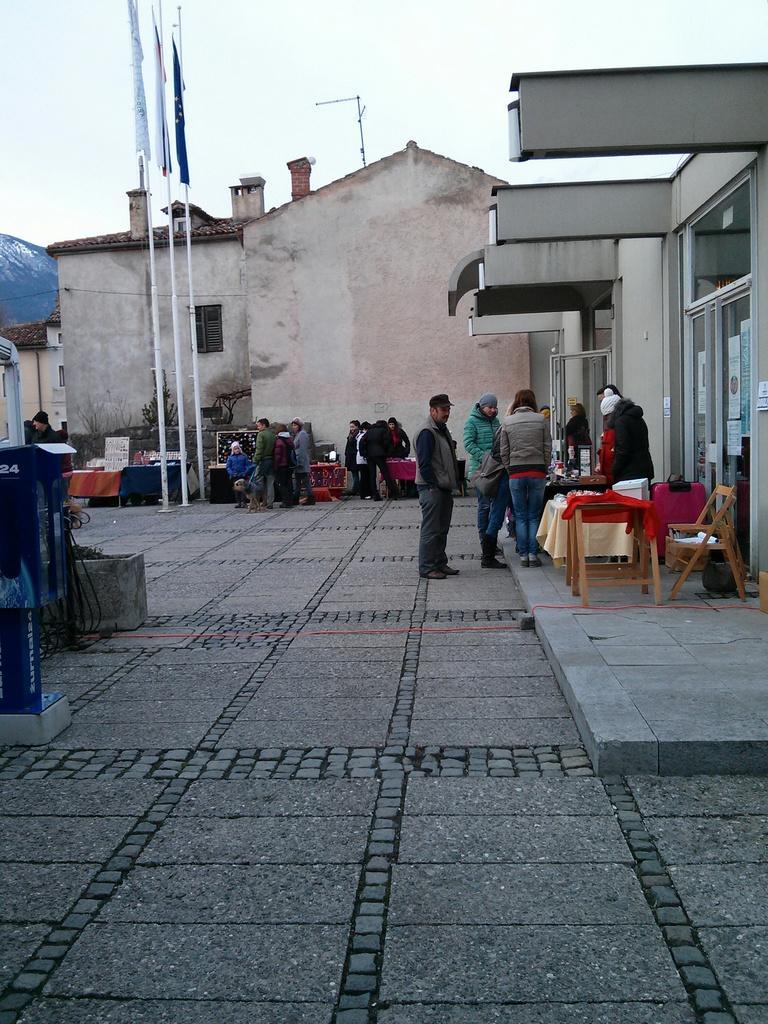How would you summarize this image in a sentence or two? In this picture there are a group of people standing over here, there is a table and there are some chairs to sit here, in the background also there are some people standing and there is a building over the left and the building a body is write the three flag poles and flags the sky is clear 